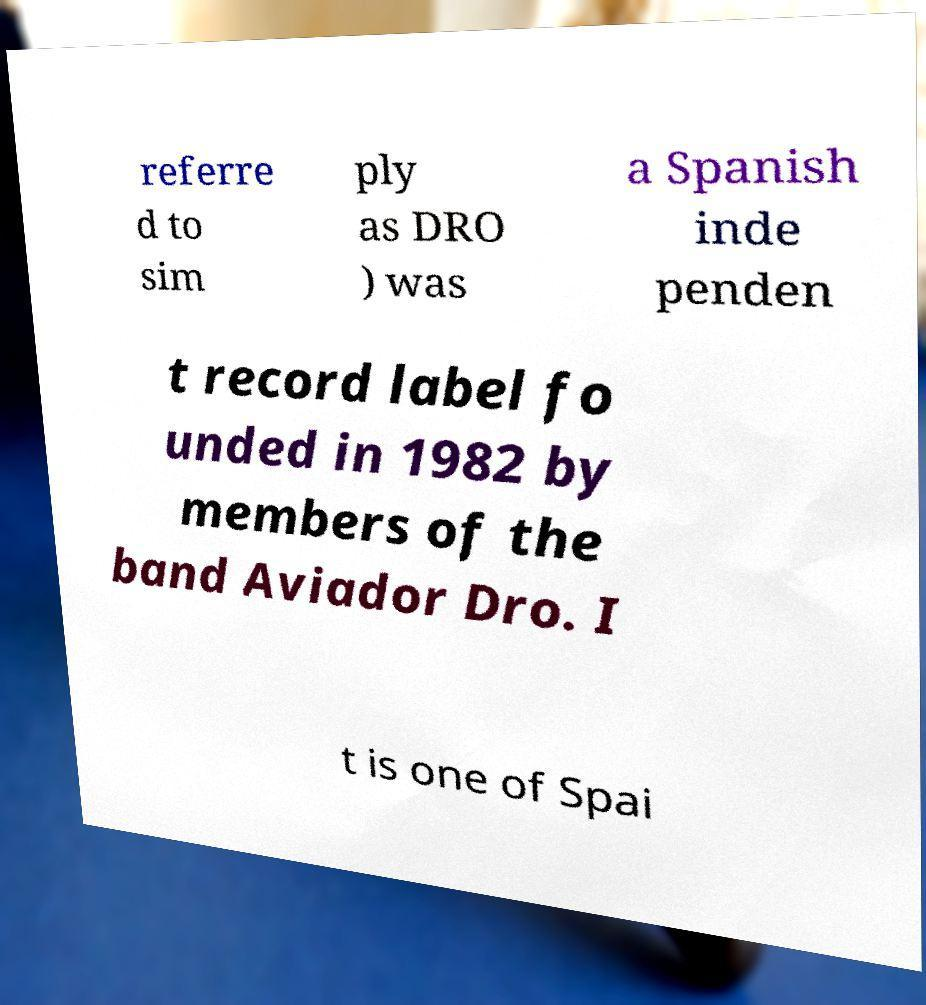For documentation purposes, I need the text within this image transcribed. Could you provide that? referre d to sim ply as DRO ) was a Spanish inde penden t record label fo unded in 1982 by members of the band Aviador Dro. I t is one of Spai 